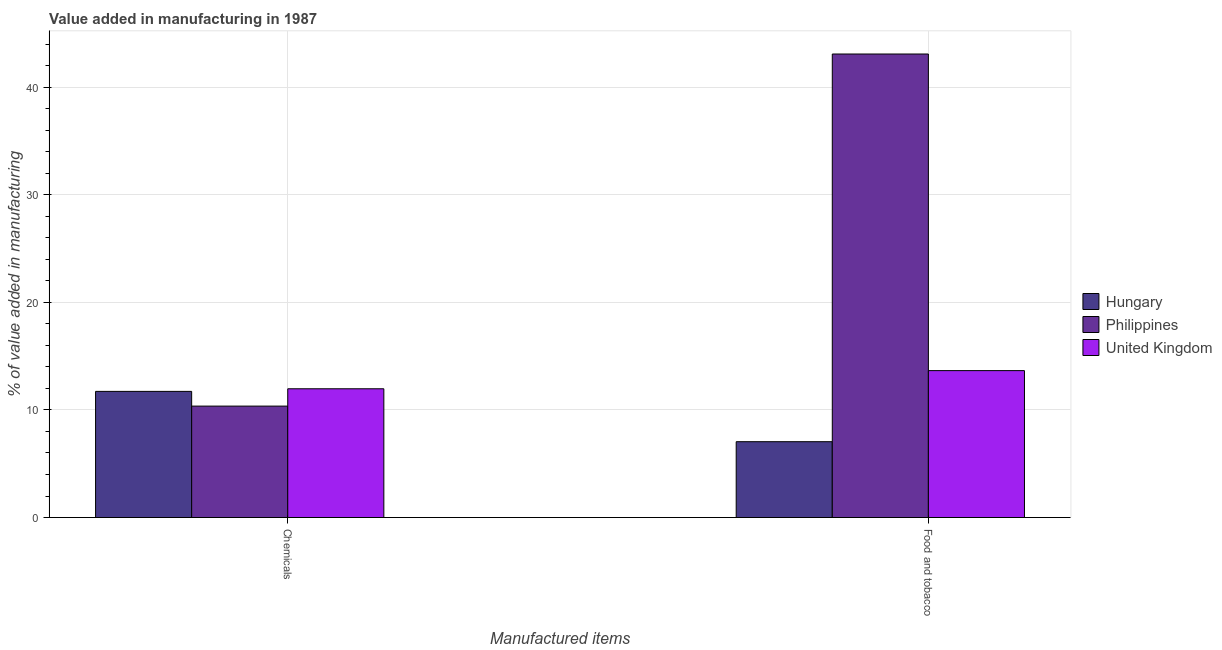Are the number of bars per tick equal to the number of legend labels?
Your answer should be very brief. Yes. What is the label of the 2nd group of bars from the left?
Provide a short and direct response. Food and tobacco. What is the value added by manufacturing food and tobacco in Hungary?
Make the answer very short. 7.05. Across all countries, what is the maximum value added by manufacturing food and tobacco?
Your answer should be very brief. 43.08. Across all countries, what is the minimum value added by manufacturing food and tobacco?
Make the answer very short. 7.05. In which country was the value added by  manufacturing chemicals maximum?
Offer a very short reply. United Kingdom. What is the total value added by  manufacturing chemicals in the graph?
Ensure brevity in your answer.  34.05. What is the difference between the value added by manufacturing food and tobacco in Philippines and that in United Kingdom?
Your response must be concise. 29.42. What is the difference between the value added by manufacturing food and tobacco in United Kingdom and the value added by  manufacturing chemicals in Philippines?
Your response must be concise. 3.3. What is the average value added by  manufacturing chemicals per country?
Your answer should be very brief. 11.35. What is the difference between the value added by  manufacturing chemicals and value added by manufacturing food and tobacco in Hungary?
Offer a very short reply. 4.68. In how many countries, is the value added by manufacturing food and tobacco greater than 36 %?
Your answer should be compact. 1. What is the ratio of the value added by  manufacturing chemicals in Philippines to that in Hungary?
Your answer should be very brief. 0.88. In how many countries, is the value added by  manufacturing chemicals greater than the average value added by  manufacturing chemicals taken over all countries?
Your answer should be very brief. 2. Are all the bars in the graph horizontal?
Provide a succinct answer. No. How many countries are there in the graph?
Provide a short and direct response. 3. Are the values on the major ticks of Y-axis written in scientific E-notation?
Keep it short and to the point. No. Where does the legend appear in the graph?
Give a very brief answer. Center right. How are the legend labels stacked?
Your answer should be compact. Vertical. What is the title of the graph?
Offer a very short reply. Value added in manufacturing in 1987. What is the label or title of the X-axis?
Keep it short and to the point. Manufactured items. What is the label or title of the Y-axis?
Your answer should be very brief. % of value added in manufacturing. What is the % of value added in manufacturing of Hungary in Chemicals?
Your answer should be very brief. 11.73. What is the % of value added in manufacturing in Philippines in Chemicals?
Make the answer very short. 10.36. What is the % of value added in manufacturing in United Kingdom in Chemicals?
Provide a succinct answer. 11.97. What is the % of value added in manufacturing in Hungary in Food and tobacco?
Give a very brief answer. 7.05. What is the % of value added in manufacturing of Philippines in Food and tobacco?
Offer a very short reply. 43.08. What is the % of value added in manufacturing in United Kingdom in Food and tobacco?
Give a very brief answer. 13.66. Across all Manufactured items, what is the maximum % of value added in manufacturing in Hungary?
Ensure brevity in your answer.  11.73. Across all Manufactured items, what is the maximum % of value added in manufacturing of Philippines?
Provide a succinct answer. 43.08. Across all Manufactured items, what is the maximum % of value added in manufacturing of United Kingdom?
Make the answer very short. 13.66. Across all Manufactured items, what is the minimum % of value added in manufacturing of Hungary?
Provide a short and direct response. 7.05. Across all Manufactured items, what is the minimum % of value added in manufacturing of Philippines?
Your response must be concise. 10.36. Across all Manufactured items, what is the minimum % of value added in manufacturing of United Kingdom?
Provide a succinct answer. 11.97. What is the total % of value added in manufacturing in Hungary in the graph?
Keep it short and to the point. 18.78. What is the total % of value added in manufacturing in Philippines in the graph?
Offer a terse response. 53.44. What is the total % of value added in manufacturing of United Kingdom in the graph?
Offer a very short reply. 25.63. What is the difference between the % of value added in manufacturing in Hungary in Chemicals and that in Food and tobacco?
Make the answer very short. 4.68. What is the difference between the % of value added in manufacturing in Philippines in Chemicals and that in Food and tobacco?
Make the answer very short. -32.72. What is the difference between the % of value added in manufacturing in United Kingdom in Chemicals and that in Food and tobacco?
Make the answer very short. -1.69. What is the difference between the % of value added in manufacturing of Hungary in Chemicals and the % of value added in manufacturing of Philippines in Food and tobacco?
Your answer should be compact. -31.35. What is the difference between the % of value added in manufacturing in Hungary in Chemicals and the % of value added in manufacturing in United Kingdom in Food and tobacco?
Offer a terse response. -1.93. What is the difference between the % of value added in manufacturing in Philippines in Chemicals and the % of value added in manufacturing in United Kingdom in Food and tobacco?
Keep it short and to the point. -3.3. What is the average % of value added in manufacturing of Hungary per Manufactured items?
Offer a very short reply. 9.39. What is the average % of value added in manufacturing in Philippines per Manufactured items?
Give a very brief answer. 26.72. What is the average % of value added in manufacturing of United Kingdom per Manufactured items?
Provide a succinct answer. 12.81. What is the difference between the % of value added in manufacturing in Hungary and % of value added in manufacturing in Philippines in Chemicals?
Offer a very short reply. 1.37. What is the difference between the % of value added in manufacturing of Hungary and % of value added in manufacturing of United Kingdom in Chemicals?
Give a very brief answer. -0.24. What is the difference between the % of value added in manufacturing of Philippines and % of value added in manufacturing of United Kingdom in Chemicals?
Give a very brief answer. -1.61. What is the difference between the % of value added in manufacturing of Hungary and % of value added in manufacturing of Philippines in Food and tobacco?
Offer a very short reply. -36.03. What is the difference between the % of value added in manufacturing in Hungary and % of value added in manufacturing in United Kingdom in Food and tobacco?
Provide a succinct answer. -6.61. What is the difference between the % of value added in manufacturing of Philippines and % of value added in manufacturing of United Kingdom in Food and tobacco?
Make the answer very short. 29.42. What is the ratio of the % of value added in manufacturing in Hungary in Chemicals to that in Food and tobacco?
Keep it short and to the point. 1.66. What is the ratio of the % of value added in manufacturing of Philippines in Chemicals to that in Food and tobacco?
Provide a short and direct response. 0.24. What is the ratio of the % of value added in manufacturing of United Kingdom in Chemicals to that in Food and tobacco?
Provide a succinct answer. 0.88. What is the difference between the highest and the second highest % of value added in manufacturing of Hungary?
Offer a terse response. 4.68. What is the difference between the highest and the second highest % of value added in manufacturing of Philippines?
Offer a terse response. 32.72. What is the difference between the highest and the second highest % of value added in manufacturing of United Kingdom?
Offer a terse response. 1.69. What is the difference between the highest and the lowest % of value added in manufacturing of Hungary?
Offer a very short reply. 4.68. What is the difference between the highest and the lowest % of value added in manufacturing in Philippines?
Give a very brief answer. 32.72. What is the difference between the highest and the lowest % of value added in manufacturing of United Kingdom?
Provide a short and direct response. 1.69. 